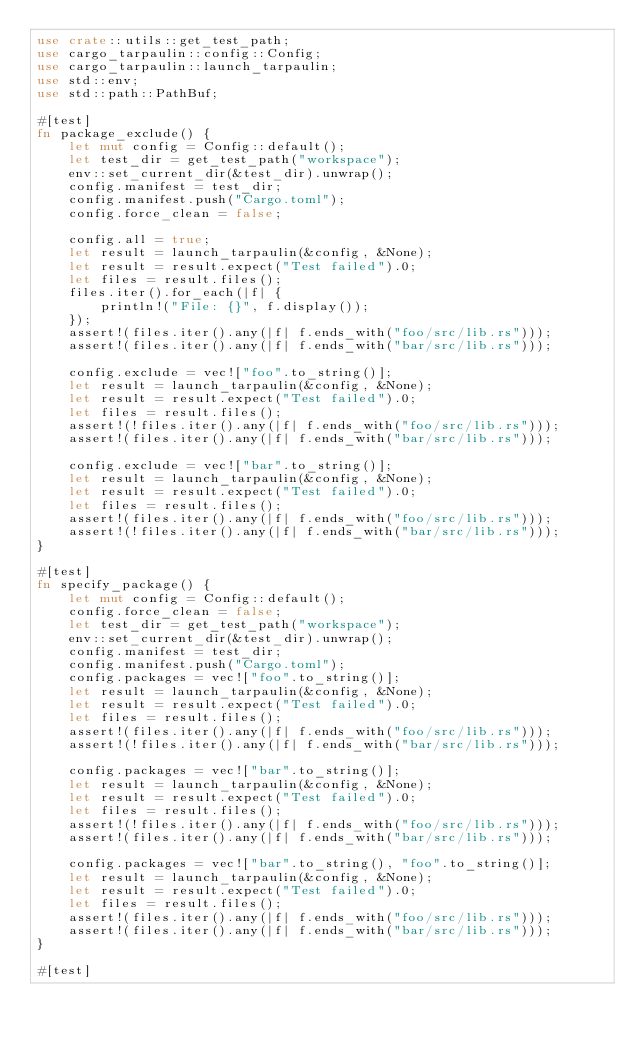Convert code to text. <code><loc_0><loc_0><loc_500><loc_500><_Rust_>use crate::utils::get_test_path;
use cargo_tarpaulin::config::Config;
use cargo_tarpaulin::launch_tarpaulin;
use std::env;
use std::path::PathBuf;

#[test]
fn package_exclude() {
    let mut config = Config::default();
    let test_dir = get_test_path("workspace");
    env::set_current_dir(&test_dir).unwrap();
    config.manifest = test_dir;
    config.manifest.push("Cargo.toml");
    config.force_clean = false;

    config.all = true;
    let result = launch_tarpaulin(&config, &None);
    let result = result.expect("Test failed").0;
    let files = result.files();
    files.iter().for_each(|f| {
        println!("File: {}", f.display());
    });
    assert!(files.iter().any(|f| f.ends_with("foo/src/lib.rs")));
    assert!(files.iter().any(|f| f.ends_with("bar/src/lib.rs")));

    config.exclude = vec!["foo".to_string()];
    let result = launch_tarpaulin(&config, &None);
    let result = result.expect("Test failed").0;
    let files = result.files();
    assert!(!files.iter().any(|f| f.ends_with("foo/src/lib.rs")));
    assert!(files.iter().any(|f| f.ends_with("bar/src/lib.rs")));

    config.exclude = vec!["bar".to_string()];
    let result = launch_tarpaulin(&config, &None);
    let result = result.expect("Test failed").0;
    let files = result.files();
    assert!(files.iter().any(|f| f.ends_with("foo/src/lib.rs")));
    assert!(!files.iter().any(|f| f.ends_with("bar/src/lib.rs")));
}

#[test]
fn specify_package() {
    let mut config = Config::default();
    config.force_clean = false;
    let test_dir = get_test_path("workspace");
    env::set_current_dir(&test_dir).unwrap();
    config.manifest = test_dir;
    config.manifest.push("Cargo.toml");
    config.packages = vec!["foo".to_string()];
    let result = launch_tarpaulin(&config, &None);
    let result = result.expect("Test failed").0;
    let files = result.files();
    assert!(files.iter().any(|f| f.ends_with("foo/src/lib.rs")));
    assert!(!files.iter().any(|f| f.ends_with("bar/src/lib.rs")));

    config.packages = vec!["bar".to_string()];
    let result = launch_tarpaulin(&config, &None);
    let result = result.expect("Test failed").0;
    let files = result.files();
    assert!(!files.iter().any(|f| f.ends_with("foo/src/lib.rs")));
    assert!(files.iter().any(|f| f.ends_with("bar/src/lib.rs")));

    config.packages = vec!["bar".to_string(), "foo".to_string()];
    let result = launch_tarpaulin(&config, &None);
    let result = result.expect("Test failed").0;
    let files = result.files();
    assert!(files.iter().any(|f| f.ends_with("foo/src/lib.rs")));
    assert!(files.iter().any(|f| f.ends_with("bar/src/lib.rs")));
}

#[test]</code> 